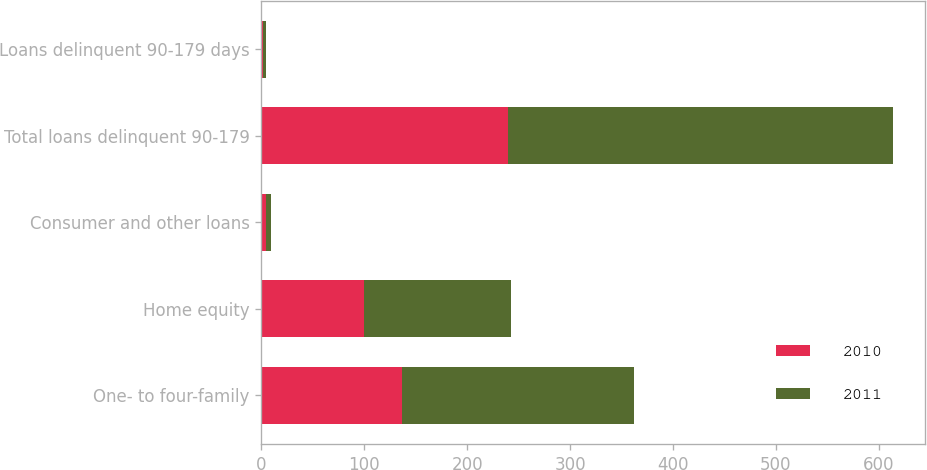Convert chart. <chart><loc_0><loc_0><loc_500><loc_500><stacked_bar_chart><ecel><fcel>One- to four-family<fcel>Home equity<fcel>Consumer and other loans<fcel>Total loans delinquent 90-179<fcel>Loans delinquent 90-179 days<nl><fcel>2010<fcel>136.2<fcel>99.7<fcel>4.1<fcel>240<fcel>1.82<nl><fcel>2011<fcel>226.1<fcel>143<fcel>4.8<fcel>373.9<fcel>2.31<nl></chart> 